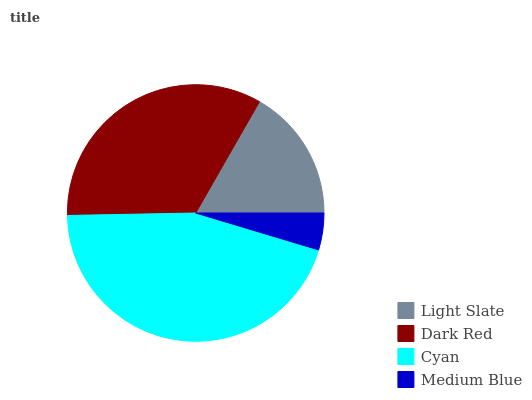Is Medium Blue the minimum?
Answer yes or no. Yes. Is Cyan the maximum?
Answer yes or no. Yes. Is Dark Red the minimum?
Answer yes or no. No. Is Dark Red the maximum?
Answer yes or no. No. Is Dark Red greater than Light Slate?
Answer yes or no. Yes. Is Light Slate less than Dark Red?
Answer yes or no. Yes. Is Light Slate greater than Dark Red?
Answer yes or no. No. Is Dark Red less than Light Slate?
Answer yes or no. No. Is Dark Red the high median?
Answer yes or no. Yes. Is Light Slate the low median?
Answer yes or no. Yes. Is Cyan the high median?
Answer yes or no. No. Is Medium Blue the low median?
Answer yes or no. No. 